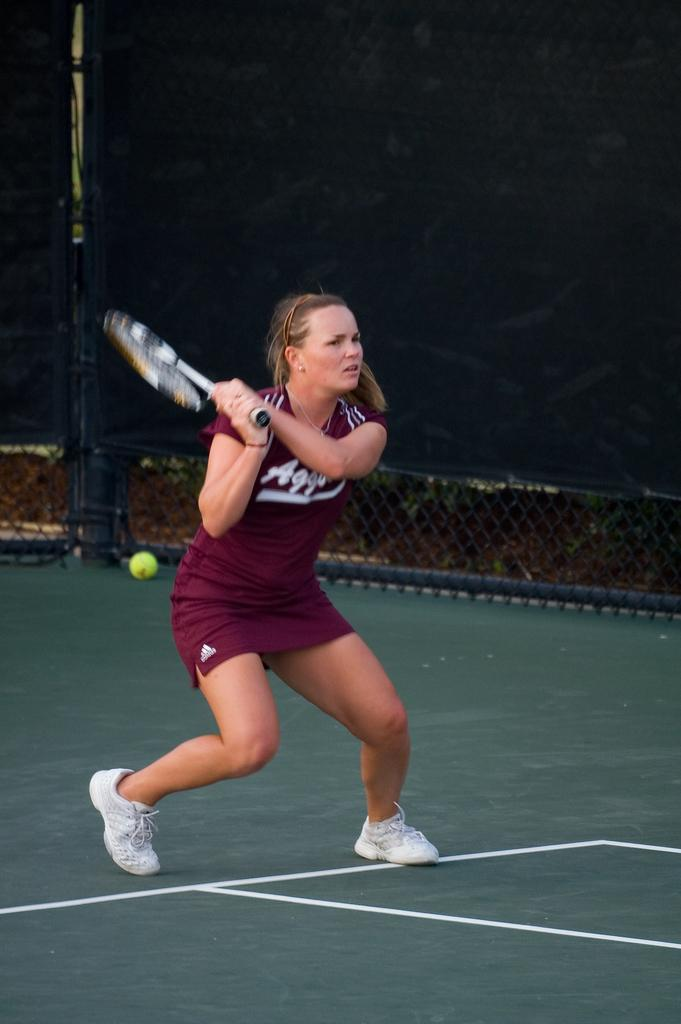What type of sports facility is shown in the image? The image depicts a tennis court. What is the woman in the image doing? The woman is playing tennis. What equipment is necessary for playing tennis in the image? There is a tennis ball and a tennis racket present in the image. What clothing items is the woman wearing? The woman is wearing a T-shirt and shoes. What type of truck is parked near the tennis court in the image? There is no truck present in the image; it only shows a tennis court and a woman playing tennis. How many family members are watching the woman play tennis in the image? There is no indication of any family members or spectators in the image; it only shows a woman playing tennis on a tennis court. 